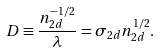<formula> <loc_0><loc_0><loc_500><loc_500>D \equiv \frac { n _ { 2 d } ^ { - 1 / 2 } } { \lambda } = \sigma _ { 2 d } n _ { 2 d } ^ { 1 / 2 } .</formula> 